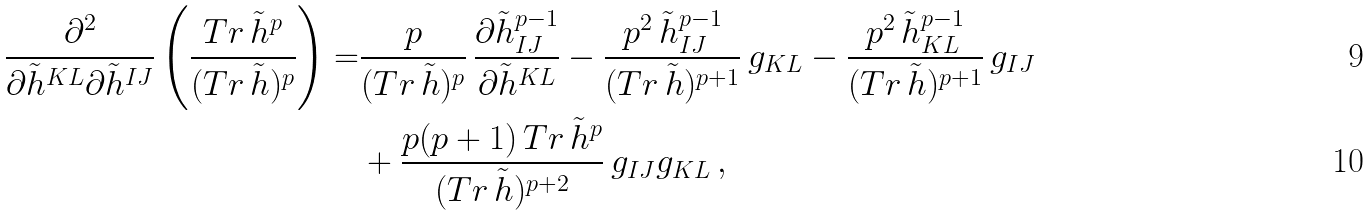Convert formula to latex. <formula><loc_0><loc_0><loc_500><loc_500>\frac { \partial ^ { 2 } } { \partial \tilde { h } ^ { K L } \partial \tilde { h } ^ { I J } } \left ( \frac { T r \, \tilde { h } ^ { p } } { ( T r \, \tilde { h } ) ^ { p } } \right ) = & \frac { p } { ( T r \, \tilde { h } ) ^ { p } } \, \frac { \partial \tilde { h } ^ { p - 1 } _ { I J } } { \partial \tilde { h } ^ { K L } } - \frac { p ^ { 2 } \, \tilde { h } ^ { p - 1 } _ { I J } } { ( T r \, \tilde { h } ) ^ { p + 1 } } \, g _ { K L } - \frac { p ^ { 2 } \, \tilde { h } ^ { p - 1 } _ { K L } } { ( T r \, \tilde { h } ) ^ { p + 1 } } \, g _ { I J } \\ & + \frac { p ( p + 1 ) \, T r \, \tilde { h } ^ { p } } { ( T r \, \tilde { h } ) ^ { p + 2 } } \, g _ { I J } g _ { K L } \, ,</formula> 